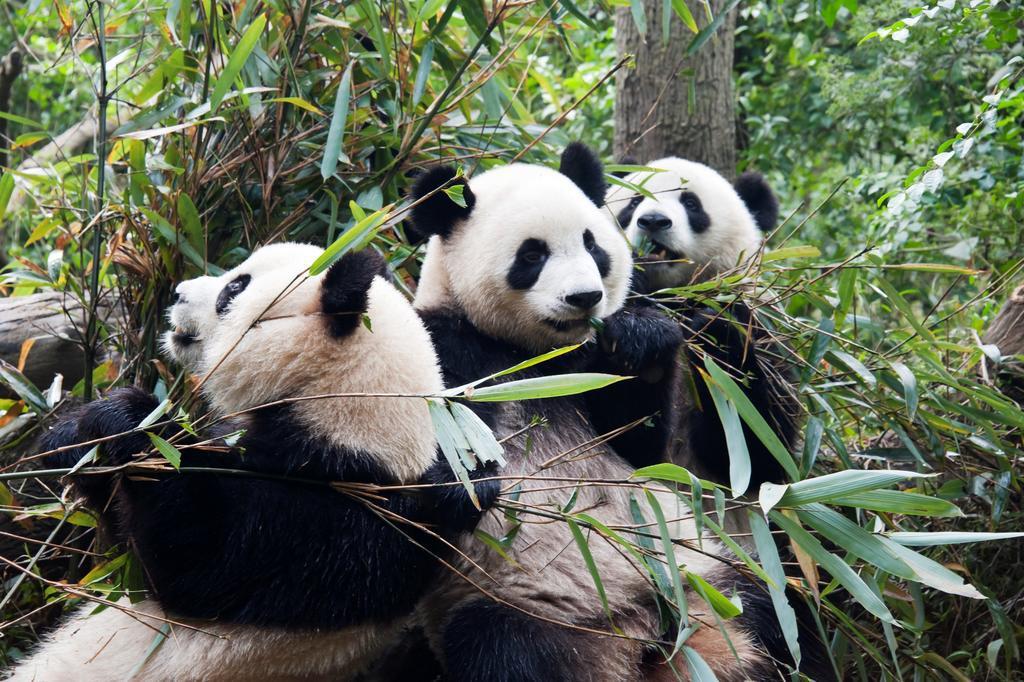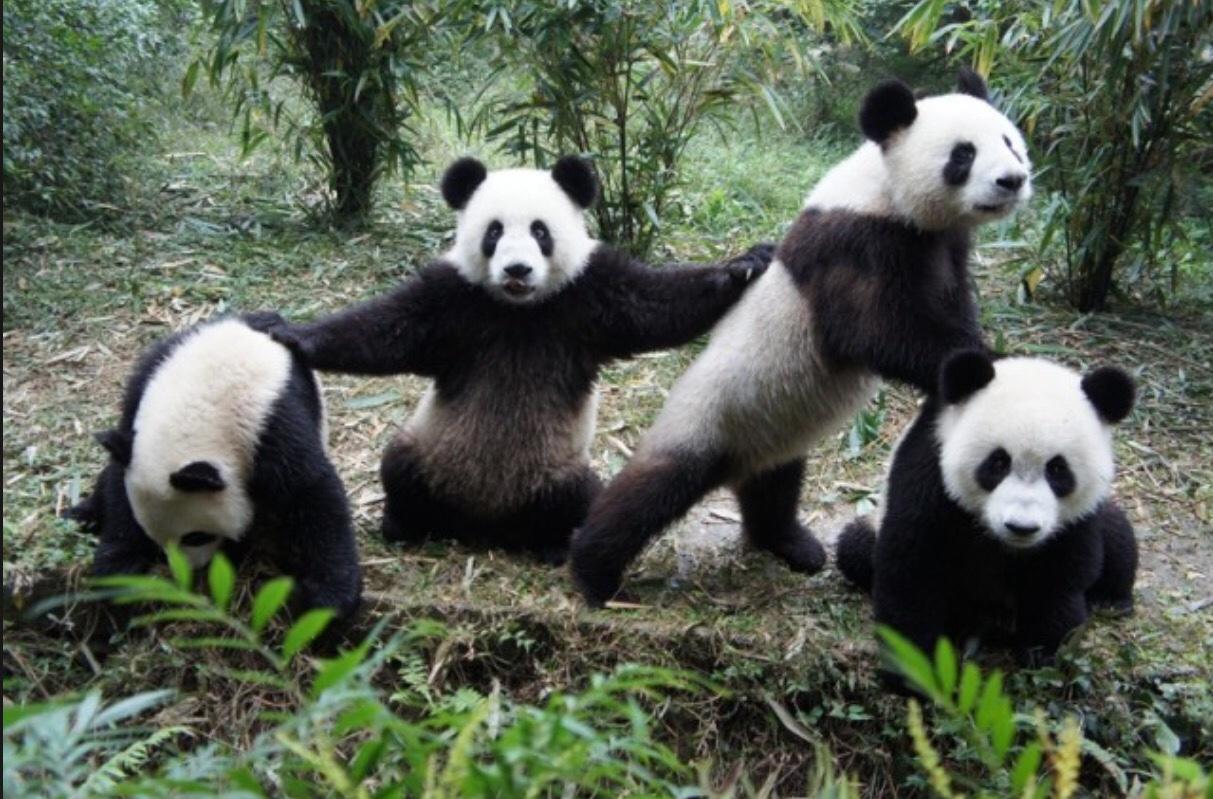The first image is the image on the left, the second image is the image on the right. Analyze the images presented: Is the assertion "An image shows multiple pandas sitting among foliage and chewing on stalks." valid? Answer yes or no. Yes. 